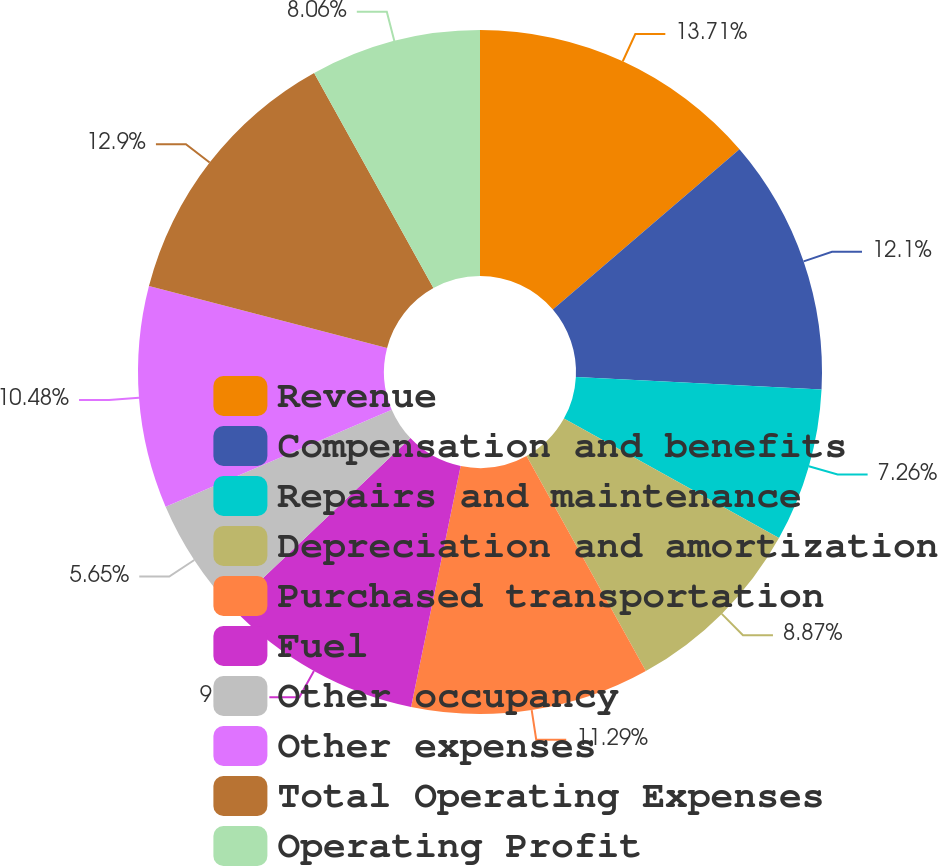<chart> <loc_0><loc_0><loc_500><loc_500><pie_chart><fcel>Revenue<fcel>Compensation and benefits<fcel>Repairs and maintenance<fcel>Depreciation and amortization<fcel>Purchased transportation<fcel>Fuel<fcel>Other occupancy<fcel>Other expenses<fcel>Total Operating Expenses<fcel>Operating Profit<nl><fcel>13.71%<fcel>12.1%<fcel>7.26%<fcel>8.87%<fcel>11.29%<fcel>9.68%<fcel>5.65%<fcel>10.48%<fcel>12.9%<fcel>8.06%<nl></chart> 